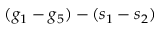Convert formula to latex. <formula><loc_0><loc_0><loc_500><loc_500>( g _ { 1 } - g _ { 5 } ) - ( s _ { 1 } - s _ { 2 } )</formula> 